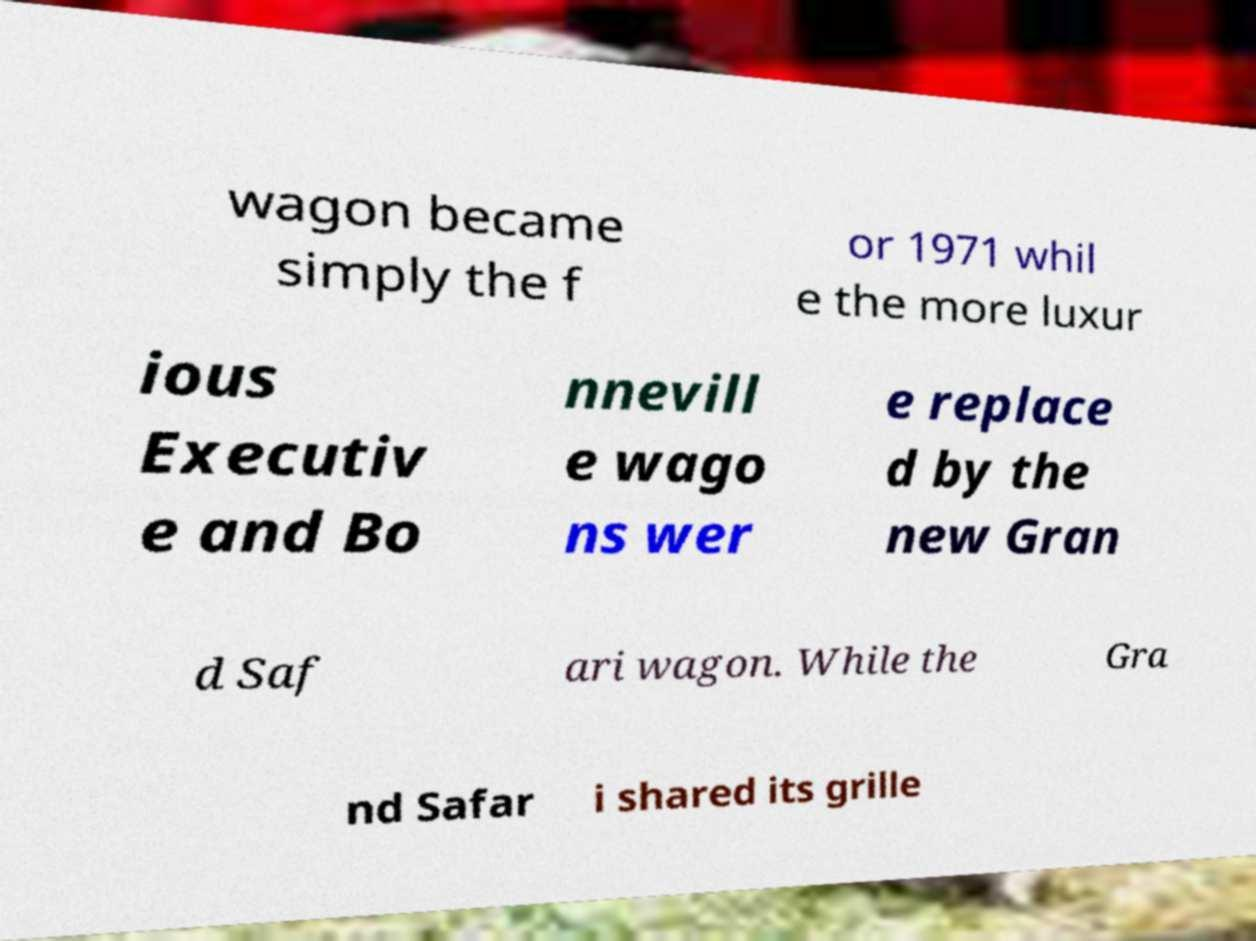Please read and relay the text visible in this image. What does it say? wagon became simply the f or 1971 whil e the more luxur ious Executiv e and Bo nnevill e wago ns wer e replace d by the new Gran d Saf ari wagon. While the Gra nd Safar i shared its grille 